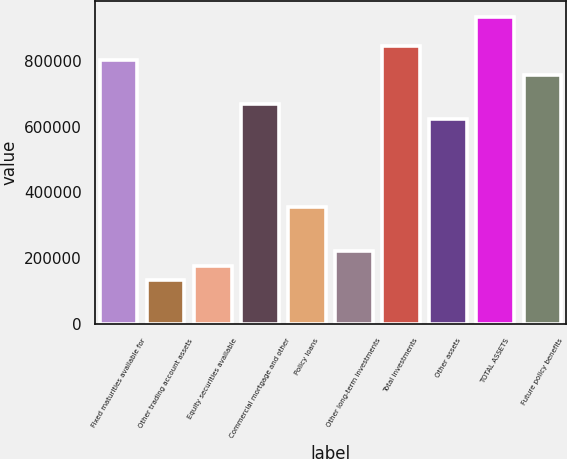<chart> <loc_0><loc_0><loc_500><loc_500><bar_chart><fcel>Fixed maturities available for<fcel>Other trading account assets<fcel>Equity securities available<fcel>Commercial mortgage and other<fcel>Policy loans<fcel>Other long-term investments<fcel>Total investments<fcel>Other assets<fcel>TOTAL ASSETS<fcel>Future policy benefits<nl><fcel>800653<fcel>133825<fcel>178280<fcel>667287<fcel>356101<fcel>222735<fcel>845108<fcel>622832<fcel>934018<fcel>756197<nl></chart> 